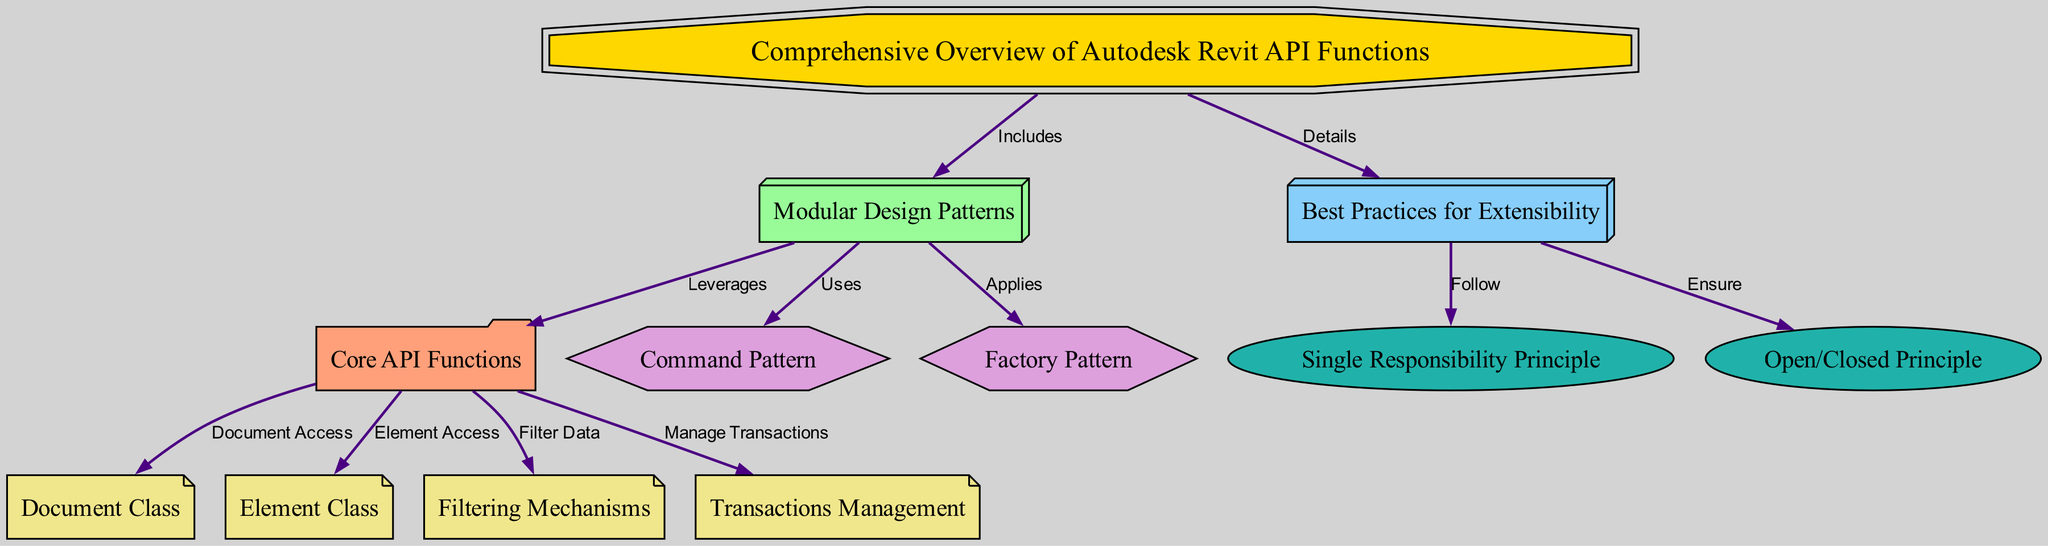What is the starting point of the diagram? The starting point is represented by the node labeled "Comprehensive Overview of Autodesk Revit API Functions." It is the initial node from which other components branch out.
Answer: Comprehensive Overview of Autodesk Revit API Functions How many nodes does the diagram contain? By counting all nodes listed in the diagram data, I find there are 12 distinct nodes.
Answer: 12 What relationship exists between 'best practices' and 'single responsibility'? The relationship is indicated by an edge where 'best practices' follows the guideline represented by 'single responsibility.' This shows that adherence to best practices encourages following the single responsibility principle.
Answer: Follow Which design pattern does the module design leverage for managing API functions? The diagram shows that the module design leverages the core API functions. This relationship is clearly established with a directed edge pointing from 'module design' to 'core API functions.'
Answer: Leverages What type of class is associated with document access in the diagram? The class associated with document access is labeled "Document Class." This is represented as a component of the core API functions, which links to document-related operations.
Answer: Document Class How many best practice principles are mentioned in the diagram? The diagram mentions two best practice principles, namely "Single Responsibility Principle" and "Open/Closed Principle," which are linked to the best practices node.
Answer: 2 What does the core functions section manage regarding transactions? The core functions section specifically manages transactions as indicated by the label connected to the transactions node, highlighting the functionality of handling transaction management in API.
Answer: Manage Transactions Which design pattern is used for creating instances in the module design? The design pattern used for creating instances is the "Factory Pattern," as indicated by its direct relationship with the module design in the diagram.
Answer: Factory Pattern What does the filtering mechanisms node enable the core API functions to do? The filtering mechanisms node enables the core API functions to filter data, as shown by the directed edge linking them together in the diagram.
Answer: Filter Data 